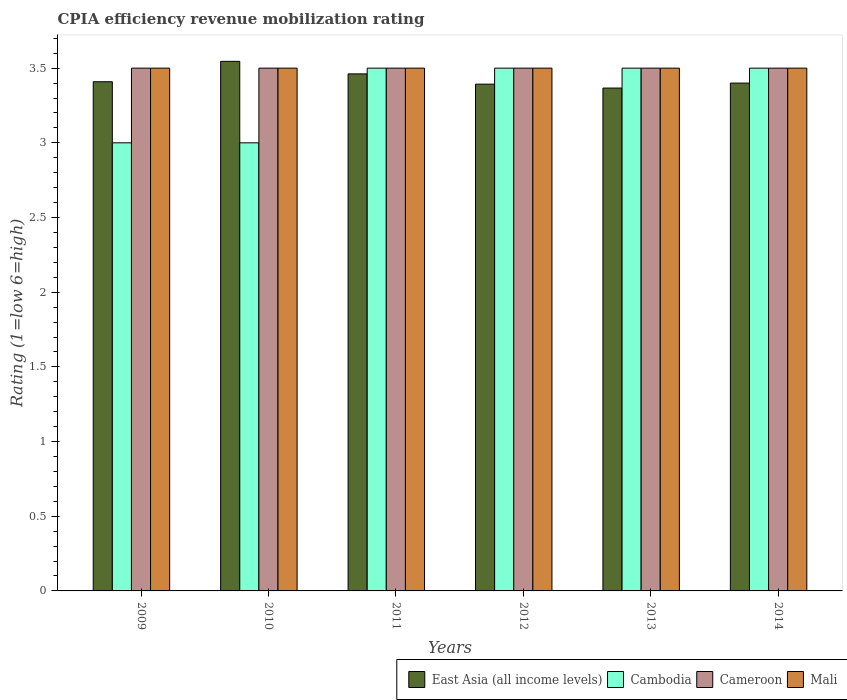How many different coloured bars are there?
Make the answer very short. 4. Are the number of bars per tick equal to the number of legend labels?
Provide a succinct answer. Yes. How many bars are there on the 2nd tick from the left?
Offer a terse response. 4. In how many cases, is the number of bars for a given year not equal to the number of legend labels?
Your answer should be compact. 0. Across all years, what is the minimum CPIA rating in East Asia (all income levels)?
Your response must be concise. 3.37. In which year was the CPIA rating in Cambodia maximum?
Your answer should be compact. 2011. In which year was the CPIA rating in Cameroon minimum?
Your answer should be compact. 2009. What is the difference between the CPIA rating in East Asia (all income levels) in 2011 and that in 2013?
Provide a short and direct response. 0.09. What is the difference between the CPIA rating in East Asia (all income levels) in 2011 and the CPIA rating in Cambodia in 2012?
Provide a succinct answer. -0.04. What is the average CPIA rating in Cambodia per year?
Provide a succinct answer. 3.33. In how many years, is the CPIA rating in Cambodia greater than 1.6?
Provide a succinct answer. 6. Is the CPIA rating in Cameroon in 2013 less than that in 2014?
Give a very brief answer. No. What is the difference between the highest and the second highest CPIA rating in East Asia (all income levels)?
Make the answer very short. 0.08. What is the difference between the highest and the lowest CPIA rating in Mali?
Give a very brief answer. 0. In how many years, is the CPIA rating in Cameroon greater than the average CPIA rating in Cameroon taken over all years?
Keep it short and to the point. 0. Is the sum of the CPIA rating in Cameroon in 2011 and 2013 greater than the maximum CPIA rating in Mali across all years?
Offer a very short reply. Yes. What does the 3rd bar from the left in 2011 represents?
Offer a very short reply. Cameroon. What does the 1st bar from the right in 2014 represents?
Your response must be concise. Mali. How many bars are there?
Ensure brevity in your answer.  24. Are the values on the major ticks of Y-axis written in scientific E-notation?
Your answer should be compact. No. Does the graph contain any zero values?
Give a very brief answer. No. Where does the legend appear in the graph?
Your response must be concise. Bottom right. How many legend labels are there?
Keep it short and to the point. 4. How are the legend labels stacked?
Make the answer very short. Horizontal. What is the title of the graph?
Your response must be concise. CPIA efficiency revenue mobilization rating. Does "Cote d'Ivoire" appear as one of the legend labels in the graph?
Provide a succinct answer. No. What is the label or title of the Y-axis?
Your answer should be very brief. Rating (1=low 6=high). What is the Rating (1=low 6=high) in East Asia (all income levels) in 2009?
Offer a very short reply. 3.41. What is the Rating (1=low 6=high) in Cameroon in 2009?
Your answer should be compact. 3.5. What is the Rating (1=low 6=high) of East Asia (all income levels) in 2010?
Provide a short and direct response. 3.55. What is the Rating (1=low 6=high) of Mali in 2010?
Your response must be concise. 3.5. What is the Rating (1=low 6=high) in East Asia (all income levels) in 2011?
Your answer should be compact. 3.46. What is the Rating (1=low 6=high) in Cambodia in 2011?
Make the answer very short. 3.5. What is the Rating (1=low 6=high) in Mali in 2011?
Make the answer very short. 3.5. What is the Rating (1=low 6=high) in East Asia (all income levels) in 2012?
Offer a very short reply. 3.39. What is the Rating (1=low 6=high) in Mali in 2012?
Your answer should be compact. 3.5. What is the Rating (1=low 6=high) in East Asia (all income levels) in 2013?
Your answer should be very brief. 3.37. What is the Rating (1=low 6=high) of Cambodia in 2013?
Ensure brevity in your answer.  3.5. What is the Rating (1=low 6=high) in East Asia (all income levels) in 2014?
Your answer should be very brief. 3.4. What is the Rating (1=low 6=high) of Cameroon in 2014?
Offer a terse response. 3.5. What is the Rating (1=low 6=high) in Mali in 2014?
Keep it short and to the point. 3.5. Across all years, what is the maximum Rating (1=low 6=high) of East Asia (all income levels)?
Offer a very short reply. 3.55. Across all years, what is the maximum Rating (1=low 6=high) of Cameroon?
Offer a terse response. 3.5. Across all years, what is the minimum Rating (1=low 6=high) in East Asia (all income levels)?
Offer a very short reply. 3.37. Across all years, what is the minimum Rating (1=low 6=high) of Cambodia?
Your response must be concise. 3. Across all years, what is the minimum Rating (1=low 6=high) of Cameroon?
Provide a succinct answer. 3.5. Across all years, what is the minimum Rating (1=low 6=high) in Mali?
Offer a terse response. 3.5. What is the total Rating (1=low 6=high) of East Asia (all income levels) in the graph?
Your answer should be very brief. 20.58. What is the total Rating (1=low 6=high) of Cambodia in the graph?
Provide a short and direct response. 20. What is the difference between the Rating (1=low 6=high) in East Asia (all income levels) in 2009 and that in 2010?
Ensure brevity in your answer.  -0.14. What is the difference between the Rating (1=low 6=high) of Cameroon in 2009 and that in 2010?
Keep it short and to the point. 0. What is the difference between the Rating (1=low 6=high) in East Asia (all income levels) in 2009 and that in 2011?
Your answer should be very brief. -0.05. What is the difference between the Rating (1=low 6=high) in Cambodia in 2009 and that in 2011?
Give a very brief answer. -0.5. What is the difference between the Rating (1=low 6=high) in Mali in 2009 and that in 2011?
Give a very brief answer. 0. What is the difference between the Rating (1=low 6=high) in East Asia (all income levels) in 2009 and that in 2012?
Make the answer very short. 0.02. What is the difference between the Rating (1=low 6=high) in Cameroon in 2009 and that in 2012?
Offer a terse response. 0. What is the difference between the Rating (1=low 6=high) of Mali in 2009 and that in 2012?
Your answer should be compact. 0. What is the difference between the Rating (1=low 6=high) in East Asia (all income levels) in 2009 and that in 2013?
Provide a succinct answer. 0.04. What is the difference between the Rating (1=low 6=high) of Cambodia in 2009 and that in 2013?
Your response must be concise. -0.5. What is the difference between the Rating (1=low 6=high) in Cameroon in 2009 and that in 2013?
Ensure brevity in your answer.  0. What is the difference between the Rating (1=low 6=high) in East Asia (all income levels) in 2009 and that in 2014?
Your response must be concise. 0.01. What is the difference between the Rating (1=low 6=high) in Cambodia in 2009 and that in 2014?
Ensure brevity in your answer.  -0.5. What is the difference between the Rating (1=low 6=high) in Cameroon in 2009 and that in 2014?
Provide a short and direct response. 0. What is the difference between the Rating (1=low 6=high) of Mali in 2009 and that in 2014?
Your answer should be compact. 0. What is the difference between the Rating (1=low 6=high) in East Asia (all income levels) in 2010 and that in 2011?
Offer a terse response. 0.08. What is the difference between the Rating (1=low 6=high) of Mali in 2010 and that in 2011?
Keep it short and to the point. 0. What is the difference between the Rating (1=low 6=high) of East Asia (all income levels) in 2010 and that in 2012?
Keep it short and to the point. 0.15. What is the difference between the Rating (1=low 6=high) of Cambodia in 2010 and that in 2012?
Ensure brevity in your answer.  -0.5. What is the difference between the Rating (1=low 6=high) in Cameroon in 2010 and that in 2012?
Offer a terse response. 0. What is the difference between the Rating (1=low 6=high) in East Asia (all income levels) in 2010 and that in 2013?
Your answer should be compact. 0.18. What is the difference between the Rating (1=low 6=high) in Cambodia in 2010 and that in 2013?
Offer a terse response. -0.5. What is the difference between the Rating (1=low 6=high) in Cameroon in 2010 and that in 2013?
Your response must be concise. 0. What is the difference between the Rating (1=low 6=high) in East Asia (all income levels) in 2010 and that in 2014?
Offer a terse response. 0.15. What is the difference between the Rating (1=low 6=high) in Cambodia in 2010 and that in 2014?
Make the answer very short. -0.5. What is the difference between the Rating (1=low 6=high) of Cameroon in 2010 and that in 2014?
Provide a succinct answer. 0. What is the difference between the Rating (1=low 6=high) in Mali in 2010 and that in 2014?
Your answer should be compact. 0. What is the difference between the Rating (1=low 6=high) in East Asia (all income levels) in 2011 and that in 2012?
Keep it short and to the point. 0.07. What is the difference between the Rating (1=low 6=high) in Cambodia in 2011 and that in 2012?
Keep it short and to the point. 0. What is the difference between the Rating (1=low 6=high) of Cameroon in 2011 and that in 2012?
Your answer should be very brief. 0. What is the difference between the Rating (1=low 6=high) of East Asia (all income levels) in 2011 and that in 2013?
Your response must be concise. 0.09. What is the difference between the Rating (1=low 6=high) in Cambodia in 2011 and that in 2013?
Offer a very short reply. 0. What is the difference between the Rating (1=low 6=high) of Cameroon in 2011 and that in 2013?
Provide a succinct answer. 0. What is the difference between the Rating (1=low 6=high) in East Asia (all income levels) in 2011 and that in 2014?
Offer a terse response. 0.06. What is the difference between the Rating (1=low 6=high) of Mali in 2011 and that in 2014?
Offer a very short reply. 0. What is the difference between the Rating (1=low 6=high) of East Asia (all income levels) in 2012 and that in 2013?
Give a very brief answer. 0.03. What is the difference between the Rating (1=low 6=high) of Cameroon in 2012 and that in 2013?
Your answer should be compact. 0. What is the difference between the Rating (1=low 6=high) of Mali in 2012 and that in 2013?
Provide a short and direct response. 0. What is the difference between the Rating (1=low 6=high) in East Asia (all income levels) in 2012 and that in 2014?
Keep it short and to the point. -0.01. What is the difference between the Rating (1=low 6=high) of Cameroon in 2012 and that in 2014?
Your response must be concise. 0. What is the difference between the Rating (1=low 6=high) in Mali in 2012 and that in 2014?
Ensure brevity in your answer.  0. What is the difference between the Rating (1=low 6=high) in East Asia (all income levels) in 2013 and that in 2014?
Keep it short and to the point. -0.03. What is the difference between the Rating (1=low 6=high) in Cambodia in 2013 and that in 2014?
Make the answer very short. 0. What is the difference between the Rating (1=low 6=high) of Cameroon in 2013 and that in 2014?
Your answer should be very brief. 0. What is the difference between the Rating (1=low 6=high) of Mali in 2013 and that in 2014?
Provide a short and direct response. 0. What is the difference between the Rating (1=low 6=high) in East Asia (all income levels) in 2009 and the Rating (1=low 6=high) in Cambodia in 2010?
Offer a terse response. 0.41. What is the difference between the Rating (1=low 6=high) in East Asia (all income levels) in 2009 and the Rating (1=low 6=high) in Cameroon in 2010?
Your response must be concise. -0.09. What is the difference between the Rating (1=low 6=high) of East Asia (all income levels) in 2009 and the Rating (1=low 6=high) of Mali in 2010?
Offer a very short reply. -0.09. What is the difference between the Rating (1=low 6=high) of East Asia (all income levels) in 2009 and the Rating (1=low 6=high) of Cambodia in 2011?
Give a very brief answer. -0.09. What is the difference between the Rating (1=low 6=high) of East Asia (all income levels) in 2009 and the Rating (1=low 6=high) of Cameroon in 2011?
Make the answer very short. -0.09. What is the difference between the Rating (1=low 6=high) in East Asia (all income levels) in 2009 and the Rating (1=low 6=high) in Mali in 2011?
Your answer should be very brief. -0.09. What is the difference between the Rating (1=low 6=high) of East Asia (all income levels) in 2009 and the Rating (1=low 6=high) of Cambodia in 2012?
Provide a succinct answer. -0.09. What is the difference between the Rating (1=low 6=high) of East Asia (all income levels) in 2009 and the Rating (1=low 6=high) of Cameroon in 2012?
Your answer should be compact. -0.09. What is the difference between the Rating (1=low 6=high) of East Asia (all income levels) in 2009 and the Rating (1=low 6=high) of Mali in 2012?
Provide a succinct answer. -0.09. What is the difference between the Rating (1=low 6=high) in Cambodia in 2009 and the Rating (1=low 6=high) in Mali in 2012?
Offer a very short reply. -0.5. What is the difference between the Rating (1=low 6=high) in East Asia (all income levels) in 2009 and the Rating (1=low 6=high) in Cambodia in 2013?
Your answer should be compact. -0.09. What is the difference between the Rating (1=low 6=high) in East Asia (all income levels) in 2009 and the Rating (1=low 6=high) in Cameroon in 2013?
Offer a terse response. -0.09. What is the difference between the Rating (1=low 6=high) in East Asia (all income levels) in 2009 and the Rating (1=low 6=high) in Mali in 2013?
Make the answer very short. -0.09. What is the difference between the Rating (1=low 6=high) in Cambodia in 2009 and the Rating (1=low 6=high) in Cameroon in 2013?
Your response must be concise. -0.5. What is the difference between the Rating (1=low 6=high) of Cambodia in 2009 and the Rating (1=low 6=high) of Mali in 2013?
Your response must be concise. -0.5. What is the difference between the Rating (1=low 6=high) in Cameroon in 2009 and the Rating (1=low 6=high) in Mali in 2013?
Your response must be concise. 0. What is the difference between the Rating (1=low 6=high) of East Asia (all income levels) in 2009 and the Rating (1=low 6=high) of Cambodia in 2014?
Make the answer very short. -0.09. What is the difference between the Rating (1=low 6=high) of East Asia (all income levels) in 2009 and the Rating (1=low 6=high) of Cameroon in 2014?
Your answer should be compact. -0.09. What is the difference between the Rating (1=low 6=high) in East Asia (all income levels) in 2009 and the Rating (1=low 6=high) in Mali in 2014?
Your response must be concise. -0.09. What is the difference between the Rating (1=low 6=high) of Cambodia in 2009 and the Rating (1=low 6=high) of Mali in 2014?
Make the answer very short. -0.5. What is the difference between the Rating (1=low 6=high) in East Asia (all income levels) in 2010 and the Rating (1=low 6=high) in Cambodia in 2011?
Keep it short and to the point. 0.05. What is the difference between the Rating (1=low 6=high) of East Asia (all income levels) in 2010 and the Rating (1=low 6=high) of Cameroon in 2011?
Give a very brief answer. 0.05. What is the difference between the Rating (1=low 6=high) in East Asia (all income levels) in 2010 and the Rating (1=low 6=high) in Mali in 2011?
Your answer should be compact. 0.05. What is the difference between the Rating (1=low 6=high) in Cameroon in 2010 and the Rating (1=low 6=high) in Mali in 2011?
Offer a very short reply. 0. What is the difference between the Rating (1=low 6=high) of East Asia (all income levels) in 2010 and the Rating (1=low 6=high) of Cambodia in 2012?
Keep it short and to the point. 0.05. What is the difference between the Rating (1=low 6=high) of East Asia (all income levels) in 2010 and the Rating (1=low 6=high) of Cameroon in 2012?
Ensure brevity in your answer.  0.05. What is the difference between the Rating (1=low 6=high) of East Asia (all income levels) in 2010 and the Rating (1=low 6=high) of Mali in 2012?
Your answer should be very brief. 0.05. What is the difference between the Rating (1=low 6=high) of East Asia (all income levels) in 2010 and the Rating (1=low 6=high) of Cambodia in 2013?
Offer a very short reply. 0.05. What is the difference between the Rating (1=low 6=high) of East Asia (all income levels) in 2010 and the Rating (1=low 6=high) of Cameroon in 2013?
Your response must be concise. 0.05. What is the difference between the Rating (1=low 6=high) in East Asia (all income levels) in 2010 and the Rating (1=low 6=high) in Mali in 2013?
Offer a very short reply. 0.05. What is the difference between the Rating (1=low 6=high) of Cambodia in 2010 and the Rating (1=low 6=high) of Cameroon in 2013?
Your answer should be compact. -0.5. What is the difference between the Rating (1=low 6=high) of Cameroon in 2010 and the Rating (1=low 6=high) of Mali in 2013?
Offer a terse response. 0. What is the difference between the Rating (1=low 6=high) of East Asia (all income levels) in 2010 and the Rating (1=low 6=high) of Cambodia in 2014?
Your answer should be compact. 0.05. What is the difference between the Rating (1=low 6=high) of East Asia (all income levels) in 2010 and the Rating (1=low 6=high) of Cameroon in 2014?
Make the answer very short. 0.05. What is the difference between the Rating (1=low 6=high) of East Asia (all income levels) in 2010 and the Rating (1=low 6=high) of Mali in 2014?
Make the answer very short. 0.05. What is the difference between the Rating (1=low 6=high) in East Asia (all income levels) in 2011 and the Rating (1=low 6=high) in Cambodia in 2012?
Provide a succinct answer. -0.04. What is the difference between the Rating (1=low 6=high) of East Asia (all income levels) in 2011 and the Rating (1=low 6=high) of Cameroon in 2012?
Ensure brevity in your answer.  -0.04. What is the difference between the Rating (1=low 6=high) in East Asia (all income levels) in 2011 and the Rating (1=low 6=high) in Mali in 2012?
Offer a terse response. -0.04. What is the difference between the Rating (1=low 6=high) of Cambodia in 2011 and the Rating (1=low 6=high) of Mali in 2012?
Your response must be concise. 0. What is the difference between the Rating (1=low 6=high) in East Asia (all income levels) in 2011 and the Rating (1=low 6=high) in Cambodia in 2013?
Provide a short and direct response. -0.04. What is the difference between the Rating (1=low 6=high) in East Asia (all income levels) in 2011 and the Rating (1=low 6=high) in Cameroon in 2013?
Keep it short and to the point. -0.04. What is the difference between the Rating (1=low 6=high) of East Asia (all income levels) in 2011 and the Rating (1=low 6=high) of Mali in 2013?
Offer a terse response. -0.04. What is the difference between the Rating (1=low 6=high) in Cambodia in 2011 and the Rating (1=low 6=high) in Cameroon in 2013?
Make the answer very short. 0. What is the difference between the Rating (1=low 6=high) in Cambodia in 2011 and the Rating (1=low 6=high) in Mali in 2013?
Your answer should be very brief. 0. What is the difference between the Rating (1=low 6=high) in East Asia (all income levels) in 2011 and the Rating (1=low 6=high) in Cambodia in 2014?
Provide a succinct answer. -0.04. What is the difference between the Rating (1=low 6=high) in East Asia (all income levels) in 2011 and the Rating (1=low 6=high) in Cameroon in 2014?
Your response must be concise. -0.04. What is the difference between the Rating (1=low 6=high) in East Asia (all income levels) in 2011 and the Rating (1=low 6=high) in Mali in 2014?
Offer a terse response. -0.04. What is the difference between the Rating (1=low 6=high) of East Asia (all income levels) in 2012 and the Rating (1=low 6=high) of Cambodia in 2013?
Offer a very short reply. -0.11. What is the difference between the Rating (1=low 6=high) of East Asia (all income levels) in 2012 and the Rating (1=low 6=high) of Cameroon in 2013?
Offer a terse response. -0.11. What is the difference between the Rating (1=low 6=high) of East Asia (all income levels) in 2012 and the Rating (1=low 6=high) of Mali in 2013?
Ensure brevity in your answer.  -0.11. What is the difference between the Rating (1=low 6=high) in Cambodia in 2012 and the Rating (1=low 6=high) in Mali in 2013?
Your response must be concise. 0. What is the difference between the Rating (1=low 6=high) in East Asia (all income levels) in 2012 and the Rating (1=low 6=high) in Cambodia in 2014?
Your answer should be compact. -0.11. What is the difference between the Rating (1=low 6=high) in East Asia (all income levels) in 2012 and the Rating (1=low 6=high) in Cameroon in 2014?
Give a very brief answer. -0.11. What is the difference between the Rating (1=low 6=high) of East Asia (all income levels) in 2012 and the Rating (1=low 6=high) of Mali in 2014?
Ensure brevity in your answer.  -0.11. What is the difference between the Rating (1=low 6=high) in Cambodia in 2012 and the Rating (1=low 6=high) in Cameroon in 2014?
Keep it short and to the point. 0. What is the difference between the Rating (1=low 6=high) of Cambodia in 2012 and the Rating (1=low 6=high) of Mali in 2014?
Keep it short and to the point. 0. What is the difference between the Rating (1=low 6=high) of Cameroon in 2012 and the Rating (1=low 6=high) of Mali in 2014?
Provide a succinct answer. 0. What is the difference between the Rating (1=low 6=high) of East Asia (all income levels) in 2013 and the Rating (1=low 6=high) of Cambodia in 2014?
Offer a very short reply. -0.13. What is the difference between the Rating (1=low 6=high) in East Asia (all income levels) in 2013 and the Rating (1=low 6=high) in Cameroon in 2014?
Give a very brief answer. -0.13. What is the difference between the Rating (1=low 6=high) of East Asia (all income levels) in 2013 and the Rating (1=low 6=high) of Mali in 2014?
Provide a short and direct response. -0.13. What is the difference between the Rating (1=low 6=high) in Cambodia in 2013 and the Rating (1=low 6=high) in Cameroon in 2014?
Make the answer very short. 0. What is the difference between the Rating (1=low 6=high) of Cameroon in 2013 and the Rating (1=low 6=high) of Mali in 2014?
Your answer should be very brief. 0. What is the average Rating (1=low 6=high) in East Asia (all income levels) per year?
Make the answer very short. 3.43. What is the average Rating (1=low 6=high) of Cambodia per year?
Your response must be concise. 3.33. In the year 2009, what is the difference between the Rating (1=low 6=high) of East Asia (all income levels) and Rating (1=low 6=high) of Cambodia?
Your response must be concise. 0.41. In the year 2009, what is the difference between the Rating (1=low 6=high) of East Asia (all income levels) and Rating (1=low 6=high) of Cameroon?
Keep it short and to the point. -0.09. In the year 2009, what is the difference between the Rating (1=low 6=high) of East Asia (all income levels) and Rating (1=low 6=high) of Mali?
Keep it short and to the point. -0.09. In the year 2009, what is the difference between the Rating (1=low 6=high) of Cambodia and Rating (1=low 6=high) of Cameroon?
Your response must be concise. -0.5. In the year 2009, what is the difference between the Rating (1=low 6=high) of Cambodia and Rating (1=low 6=high) of Mali?
Provide a short and direct response. -0.5. In the year 2010, what is the difference between the Rating (1=low 6=high) of East Asia (all income levels) and Rating (1=low 6=high) of Cambodia?
Make the answer very short. 0.55. In the year 2010, what is the difference between the Rating (1=low 6=high) in East Asia (all income levels) and Rating (1=low 6=high) in Cameroon?
Offer a very short reply. 0.05. In the year 2010, what is the difference between the Rating (1=low 6=high) of East Asia (all income levels) and Rating (1=low 6=high) of Mali?
Your response must be concise. 0.05. In the year 2010, what is the difference between the Rating (1=low 6=high) of Cambodia and Rating (1=low 6=high) of Cameroon?
Make the answer very short. -0.5. In the year 2010, what is the difference between the Rating (1=low 6=high) of Cambodia and Rating (1=low 6=high) of Mali?
Provide a short and direct response. -0.5. In the year 2011, what is the difference between the Rating (1=low 6=high) of East Asia (all income levels) and Rating (1=low 6=high) of Cambodia?
Your answer should be very brief. -0.04. In the year 2011, what is the difference between the Rating (1=low 6=high) of East Asia (all income levels) and Rating (1=low 6=high) of Cameroon?
Your answer should be compact. -0.04. In the year 2011, what is the difference between the Rating (1=low 6=high) of East Asia (all income levels) and Rating (1=low 6=high) of Mali?
Offer a very short reply. -0.04. In the year 2011, what is the difference between the Rating (1=low 6=high) of Cambodia and Rating (1=low 6=high) of Cameroon?
Provide a short and direct response. 0. In the year 2012, what is the difference between the Rating (1=low 6=high) in East Asia (all income levels) and Rating (1=low 6=high) in Cambodia?
Your response must be concise. -0.11. In the year 2012, what is the difference between the Rating (1=low 6=high) of East Asia (all income levels) and Rating (1=low 6=high) of Cameroon?
Your response must be concise. -0.11. In the year 2012, what is the difference between the Rating (1=low 6=high) of East Asia (all income levels) and Rating (1=low 6=high) of Mali?
Provide a succinct answer. -0.11. In the year 2012, what is the difference between the Rating (1=low 6=high) in Cameroon and Rating (1=low 6=high) in Mali?
Your answer should be compact. 0. In the year 2013, what is the difference between the Rating (1=low 6=high) of East Asia (all income levels) and Rating (1=low 6=high) of Cambodia?
Make the answer very short. -0.13. In the year 2013, what is the difference between the Rating (1=low 6=high) in East Asia (all income levels) and Rating (1=low 6=high) in Cameroon?
Keep it short and to the point. -0.13. In the year 2013, what is the difference between the Rating (1=low 6=high) in East Asia (all income levels) and Rating (1=low 6=high) in Mali?
Keep it short and to the point. -0.13. In the year 2013, what is the difference between the Rating (1=low 6=high) in Cambodia and Rating (1=low 6=high) in Cameroon?
Offer a very short reply. 0. In the year 2013, what is the difference between the Rating (1=low 6=high) of Cambodia and Rating (1=low 6=high) of Mali?
Make the answer very short. 0. In the year 2013, what is the difference between the Rating (1=low 6=high) in Cameroon and Rating (1=low 6=high) in Mali?
Offer a terse response. 0. In the year 2014, what is the difference between the Rating (1=low 6=high) in East Asia (all income levels) and Rating (1=low 6=high) in Cambodia?
Ensure brevity in your answer.  -0.1. In the year 2014, what is the difference between the Rating (1=low 6=high) of Cameroon and Rating (1=low 6=high) of Mali?
Offer a terse response. 0. What is the ratio of the Rating (1=low 6=high) in East Asia (all income levels) in 2009 to that in 2010?
Your answer should be compact. 0.96. What is the ratio of the Rating (1=low 6=high) in Cambodia in 2009 to that in 2010?
Keep it short and to the point. 1. What is the ratio of the Rating (1=low 6=high) of East Asia (all income levels) in 2009 to that in 2011?
Keep it short and to the point. 0.98. What is the ratio of the Rating (1=low 6=high) of Cambodia in 2009 to that in 2011?
Offer a very short reply. 0.86. What is the ratio of the Rating (1=low 6=high) of Cambodia in 2009 to that in 2012?
Keep it short and to the point. 0.86. What is the ratio of the Rating (1=low 6=high) in East Asia (all income levels) in 2009 to that in 2013?
Keep it short and to the point. 1.01. What is the ratio of the Rating (1=low 6=high) in Cameroon in 2009 to that in 2013?
Make the answer very short. 1. What is the ratio of the Rating (1=low 6=high) of East Asia (all income levels) in 2009 to that in 2014?
Make the answer very short. 1. What is the ratio of the Rating (1=low 6=high) of Cambodia in 2009 to that in 2014?
Give a very brief answer. 0.86. What is the ratio of the Rating (1=low 6=high) in Cameroon in 2009 to that in 2014?
Keep it short and to the point. 1. What is the ratio of the Rating (1=low 6=high) in East Asia (all income levels) in 2010 to that in 2011?
Ensure brevity in your answer.  1.02. What is the ratio of the Rating (1=low 6=high) in East Asia (all income levels) in 2010 to that in 2012?
Make the answer very short. 1.04. What is the ratio of the Rating (1=low 6=high) in East Asia (all income levels) in 2010 to that in 2013?
Your answer should be compact. 1.05. What is the ratio of the Rating (1=low 6=high) of Cambodia in 2010 to that in 2013?
Your answer should be compact. 0.86. What is the ratio of the Rating (1=low 6=high) in Mali in 2010 to that in 2013?
Offer a terse response. 1. What is the ratio of the Rating (1=low 6=high) of East Asia (all income levels) in 2010 to that in 2014?
Your answer should be compact. 1.04. What is the ratio of the Rating (1=low 6=high) in East Asia (all income levels) in 2011 to that in 2012?
Offer a terse response. 1.02. What is the ratio of the Rating (1=low 6=high) of Cambodia in 2011 to that in 2012?
Provide a short and direct response. 1. What is the ratio of the Rating (1=low 6=high) in East Asia (all income levels) in 2011 to that in 2013?
Ensure brevity in your answer.  1.03. What is the ratio of the Rating (1=low 6=high) in Cambodia in 2011 to that in 2013?
Ensure brevity in your answer.  1. What is the ratio of the Rating (1=low 6=high) of Cameroon in 2011 to that in 2013?
Keep it short and to the point. 1. What is the ratio of the Rating (1=low 6=high) of Mali in 2011 to that in 2013?
Provide a succinct answer. 1. What is the ratio of the Rating (1=low 6=high) in East Asia (all income levels) in 2011 to that in 2014?
Provide a succinct answer. 1.02. What is the ratio of the Rating (1=low 6=high) in Cambodia in 2011 to that in 2014?
Make the answer very short. 1. What is the ratio of the Rating (1=low 6=high) in Mali in 2011 to that in 2014?
Offer a terse response. 1. What is the ratio of the Rating (1=low 6=high) of East Asia (all income levels) in 2012 to that in 2013?
Make the answer very short. 1.01. What is the ratio of the Rating (1=low 6=high) of Cambodia in 2012 to that in 2013?
Offer a very short reply. 1. What is the ratio of the Rating (1=low 6=high) in Cambodia in 2012 to that in 2014?
Provide a short and direct response. 1. What is the ratio of the Rating (1=low 6=high) of Cameroon in 2012 to that in 2014?
Give a very brief answer. 1. What is the ratio of the Rating (1=low 6=high) in Mali in 2012 to that in 2014?
Your answer should be compact. 1. What is the ratio of the Rating (1=low 6=high) of East Asia (all income levels) in 2013 to that in 2014?
Ensure brevity in your answer.  0.99. What is the difference between the highest and the second highest Rating (1=low 6=high) of East Asia (all income levels)?
Your answer should be compact. 0.08. What is the difference between the highest and the second highest Rating (1=low 6=high) of Mali?
Make the answer very short. 0. What is the difference between the highest and the lowest Rating (1=low 6=high) in East Asia (all income levels)?
Provide a succinct answer. 0.18. What is the difference between the highest and the lowest Rating (1=low 6=high) of Mali?
Your response must be concise. 0. 